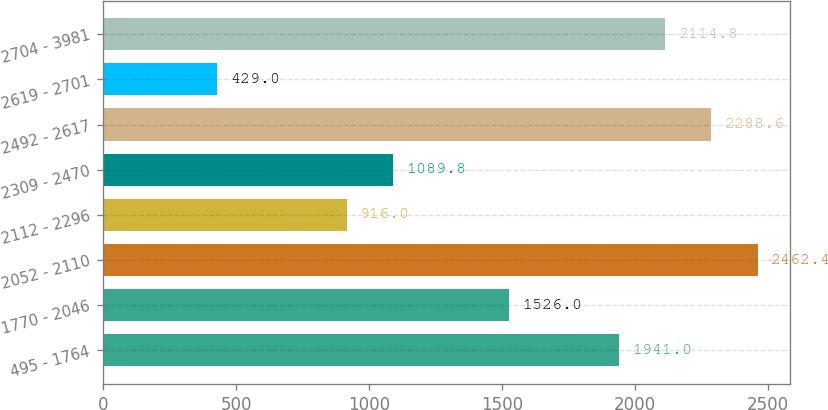Convert chart to OTSL. <chart><loc_0><loc_0><loc_500><loc_500><bar_chart><fcel>495 - 1764<fcel>1770 - 2046<fcel>2052 - 2110<fcel>2112 - 2296<fcel>2309 - 2470<fcel>2492 - 2617<fcel>2619 - 2701<fcel>2704 - 3981<nl><fcel>1941<fcel>1526<fcel>2462.4<fcel>916<fcel>1089.8<fcel>2288.6<fcel>429<fcel>2114.8<nl></chart> 